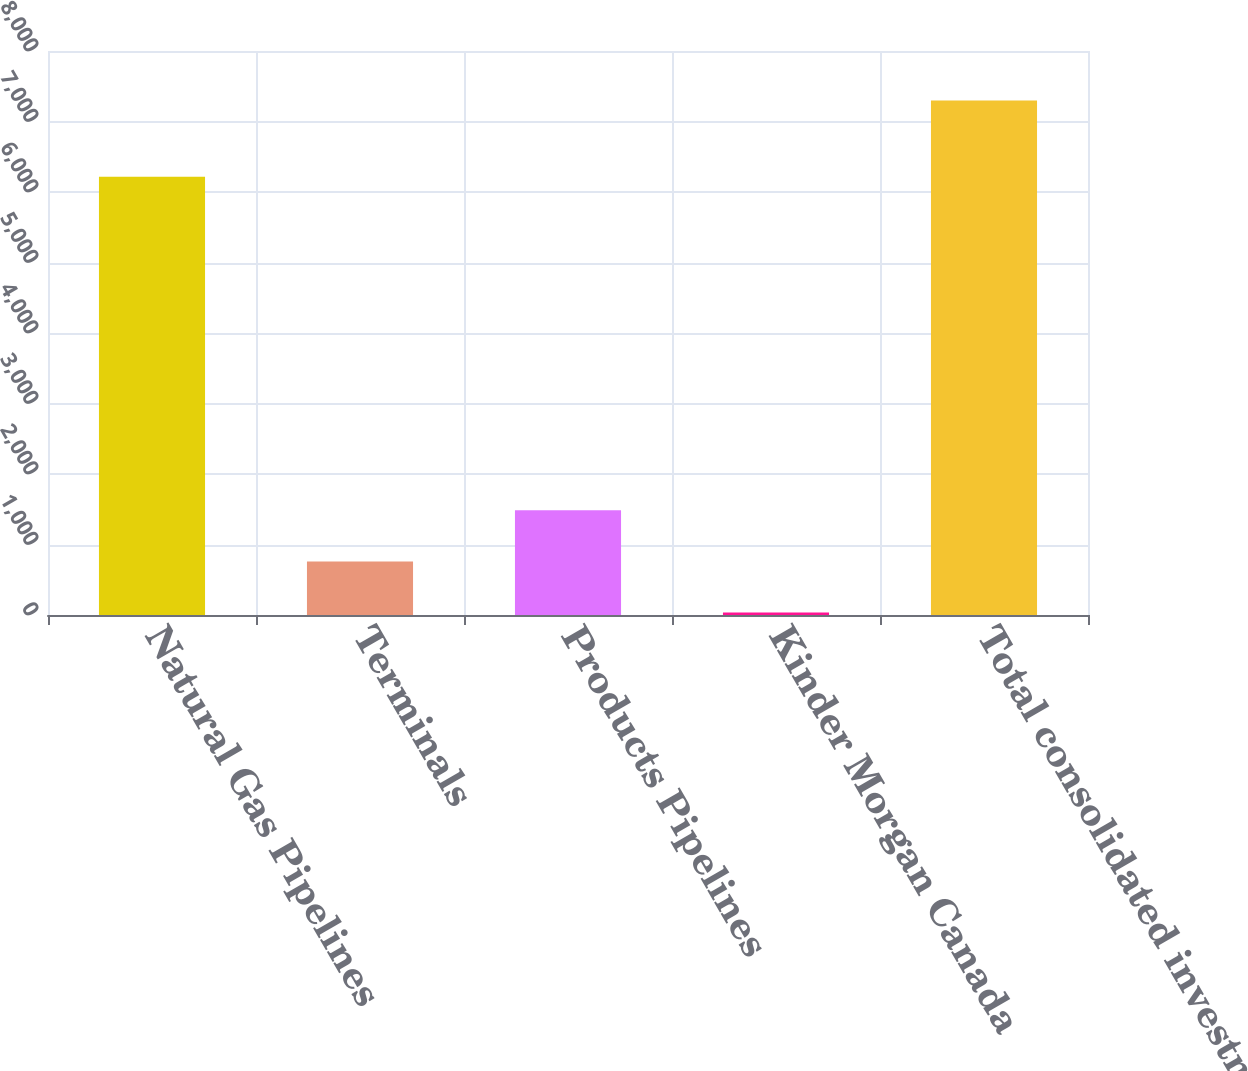<chart> <loc_0><loc_0><loc_500><loc_500><bar_chart><fcel>Natural Gas Pipelines<fcel>Terminals<fcel>Products Pipelines<fcel>Kinder Morgan Canada<fcel>Total consolidated investments<nl><fcel>6218<fcel>760.4<fcel>1486.8<fcel>34<fcel>7298<nl></chart> 